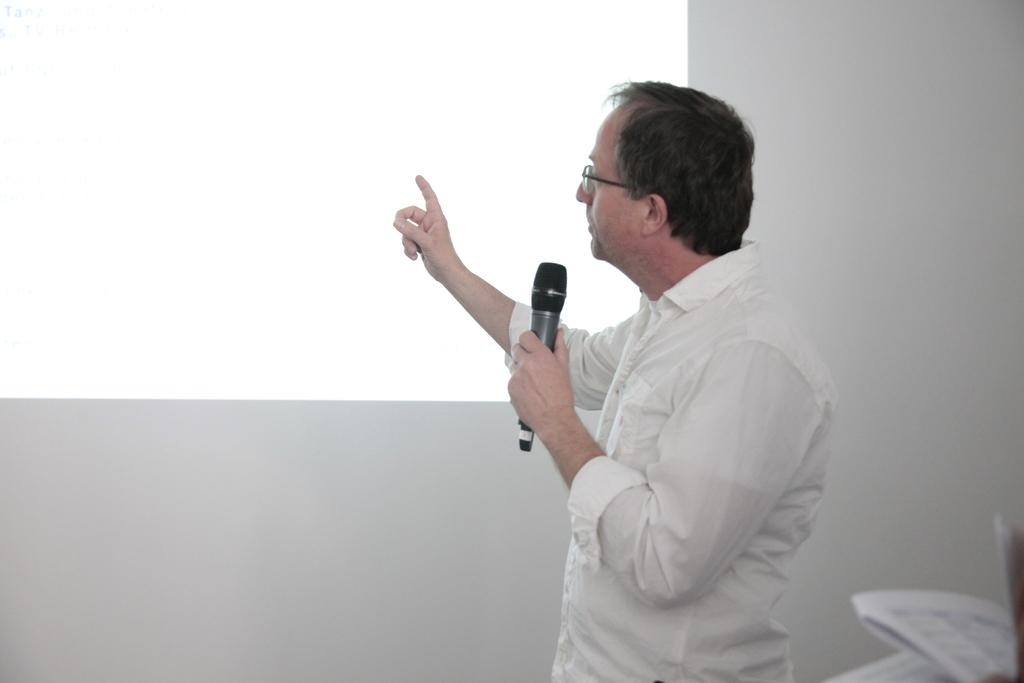What is the person in the image doing? The person is standing and holding a microphone. What can be seen in the background of the image? There is a wall in the background of the image. Are there any additional items visible at the bottom right side of the image? Yes, there are papers at the bottom right side of the image. What type of muscle is being exercised by the person in the image? There is no indication of any muscle exercise in the image; the person is simply standing and holding a microphone. 